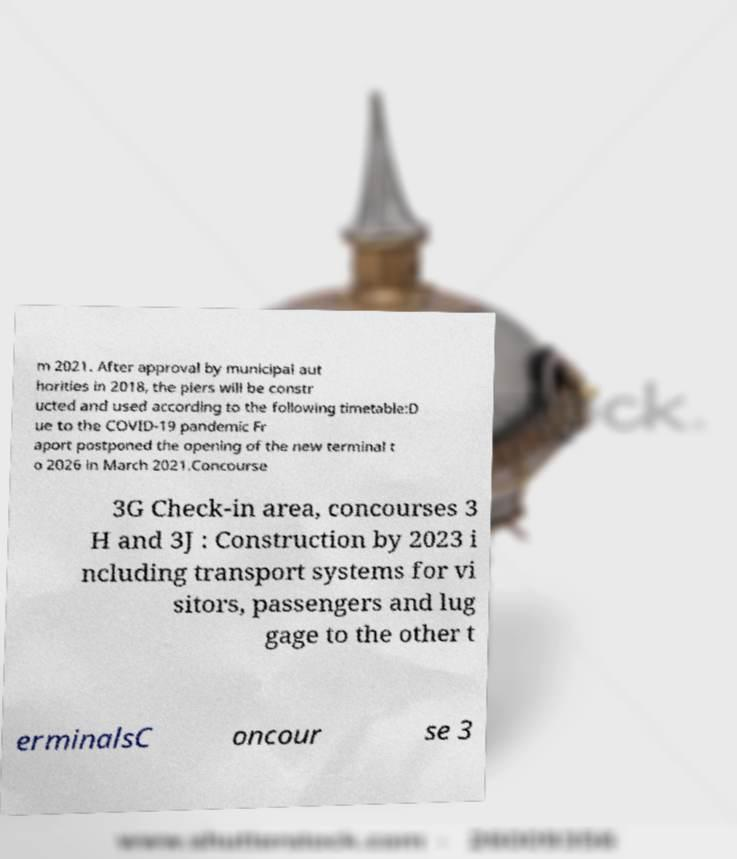For documentation purposes, I need the text within this image transcribed. Could you provide that? m 2021. After approval by municipal aut horities in 2018, the piers will be constr ucted and used according to the following timetable:D ue to the COVID-19 pandemic Fr aport postponed the opening of the new terminal t o 2026 in March 2021.Concourse 3G Check-in area, concourses 3 H and 3J : Construction by 2023 i ncluding transport systems for vi sitors, passengers and lug gage to the other t erminalsC oncour se 3 